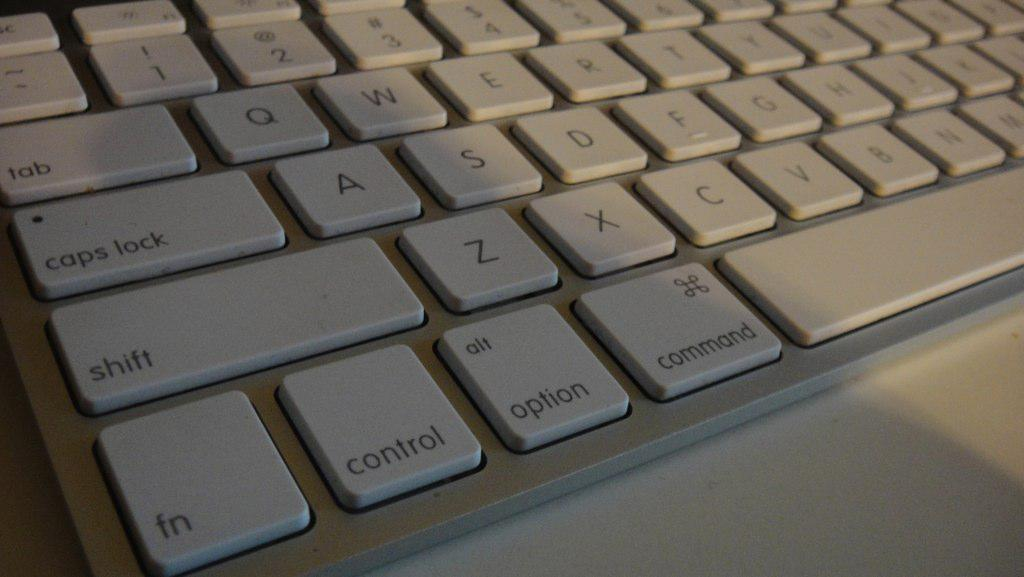<image>
Present a compact description of the photo's key features. the word control is on the bottom of the computer 